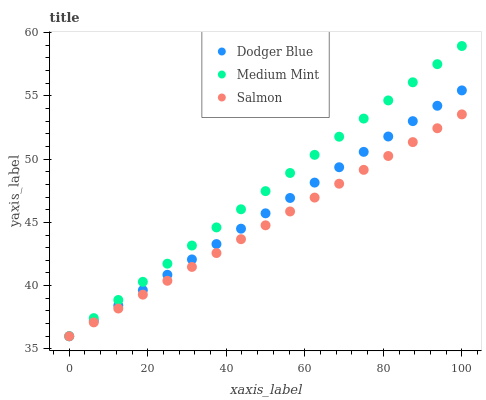Does Salmon have the minimum area under the curve?
Answer yes or no. Yes. Does Medium Mint have the maximum area under the curve?
Answer yes or no. Yes. Does Dodger Blue have the minimum area under the curve?
Answer yes or no. No. Does Dodger Blue have the maximum area under the curve?
Answer yes or no. No. Is Salmon the smoothest?
Answer yes or no. Yes. Is Dodger Blue the roughest?
Answer yes or no. Yes. Is Dodger Blue the smoothest?
Answer yes or no. No. Is Salmon the roughest?
Answer yes or no. No. Does Medium Mint have the lowest value?
Answer yes or no. Yes. Does Medium Mint have the highest value?
Answer yes or no. Yes. Does Dodger Blue have the highest value?
Answer yes or no. No. Does Dodger Blue intersect Salmon?
Answer yes or no. Yes. Is Dodger Blue less than Salmon?
Answer yes or no. No. Is Dodger Blue greater than Salmon?
Answer yes or no. No. 